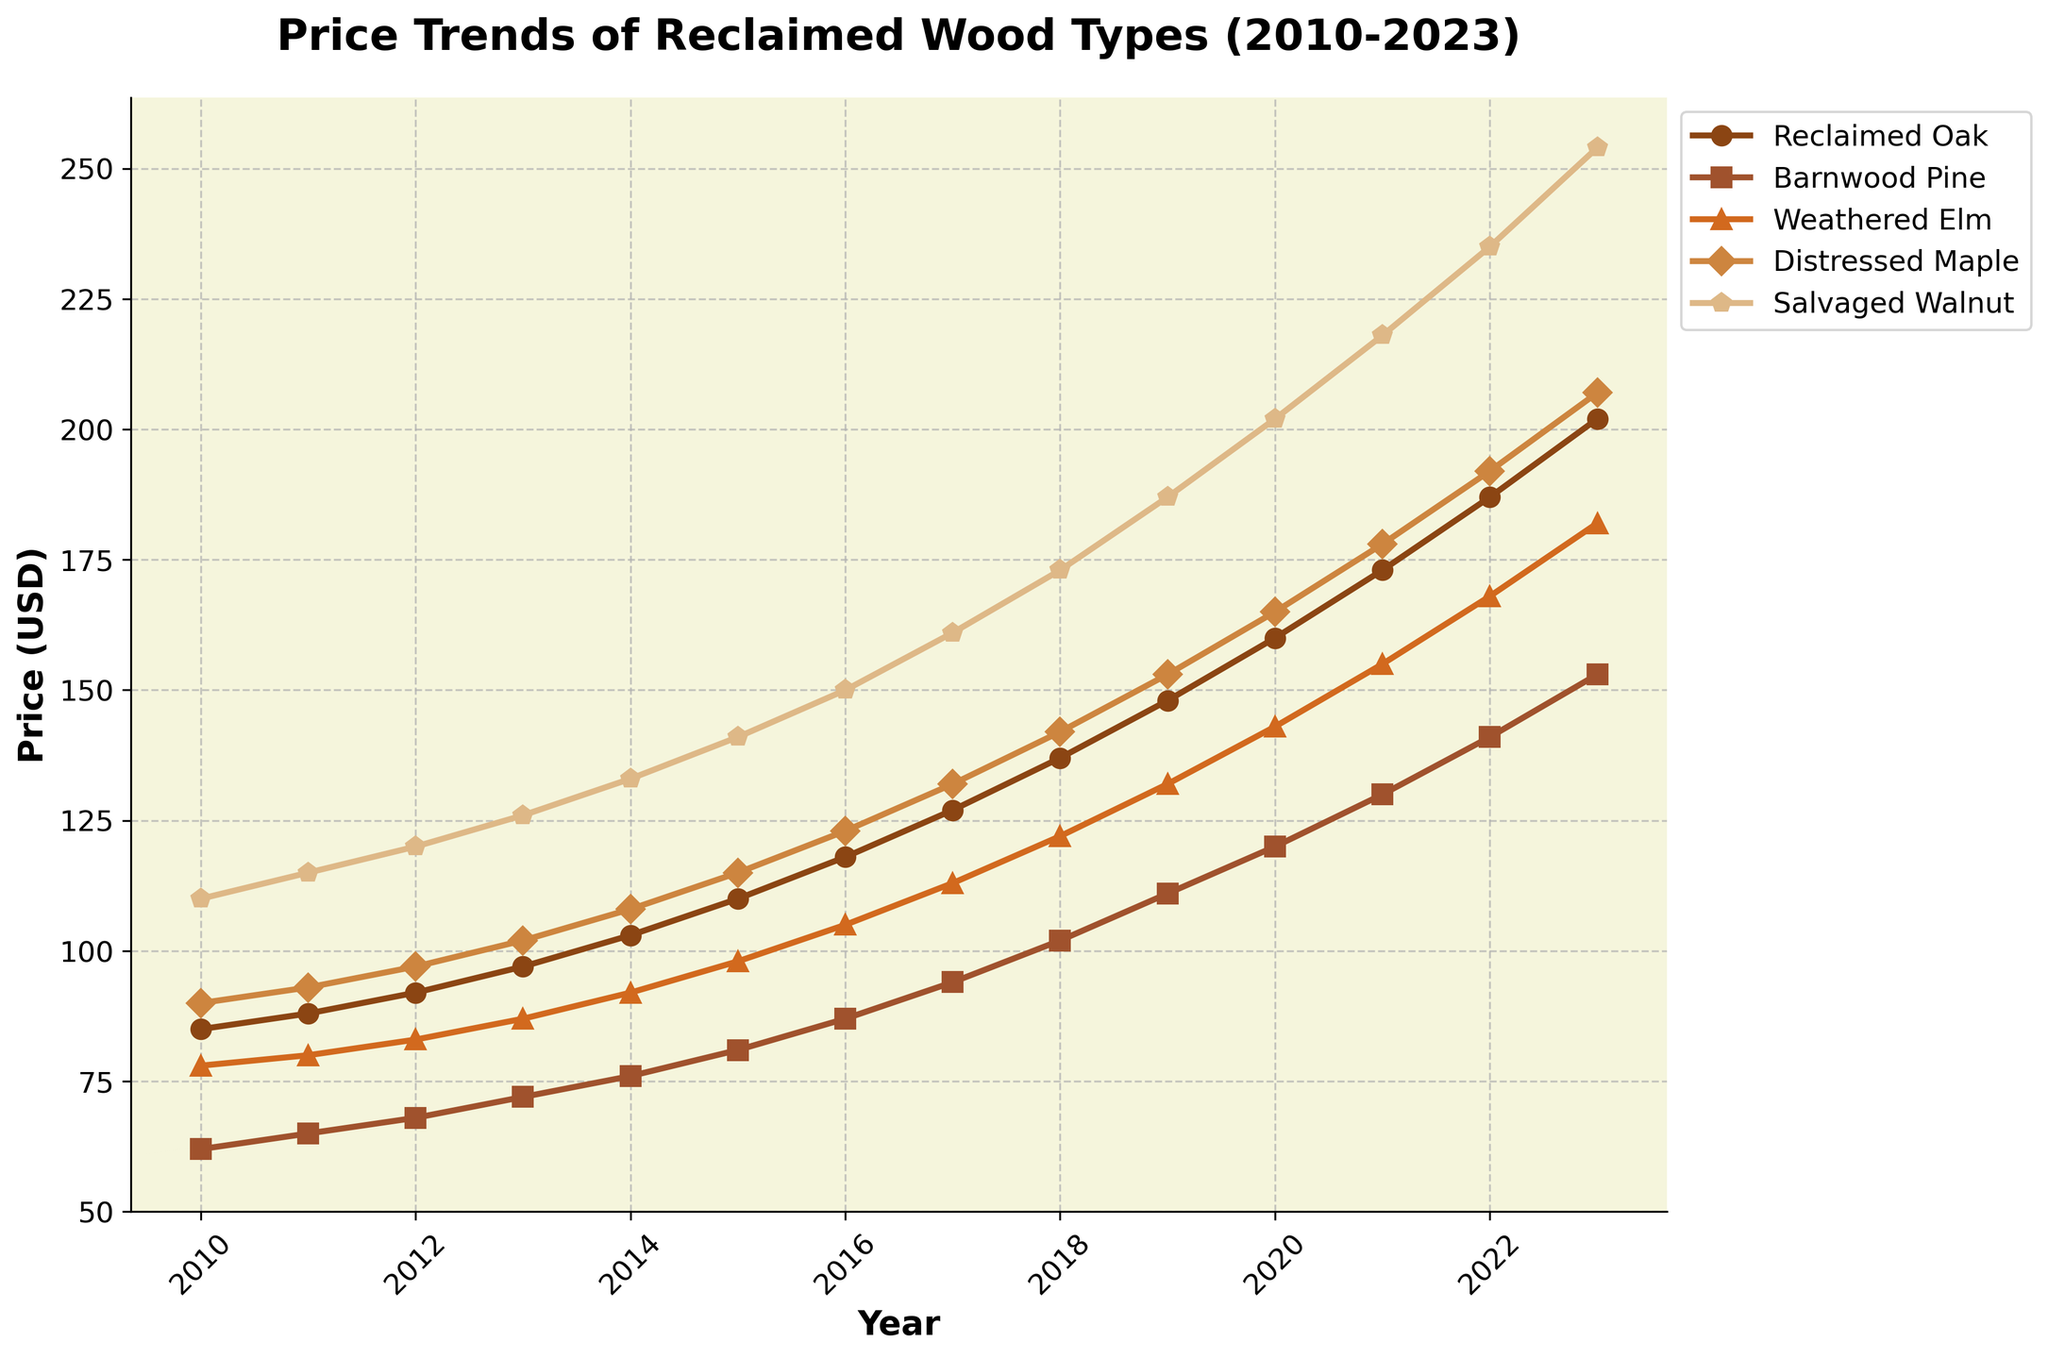What is the overall trend in the price of Reclaimed Oak from 2010 to 2023? The price of Reclaimed Oak shows a consistent upward trend from 2010 to 2023. Initially, in 2010, the price is $85, and it progressively increases each year, reaching $202 by 2023.
Answer: Upward trend How does the price of Salvaged Walnut in 2013 compare to the price of Distressed Maple in the same year? In 2013, the price of Salvaged Walnut is $126, whereas the price of Distressed Maple is $102. Thus, the price of Salvaged Walnut is higher than that of Distressed Maple in 2013.
Answer: Higher Which wood type experienced the steepest increase in price from 2019 to 2023? From 2019 to 2023, Salvaged Walnut increased from $187 to $254, an increase of $67. Reclaimed Oak increased by $54, Barnwood Pine by $42, Weathered Elm by $50, and Distressed Maple by $54. Salvaged Walnut experienced the steepest increase.
Answer: Salvaged Walnut What are the price differences between the most expensive and least expensive wood types in 2021? In 2021, the most expensive wood type is Salvaged Walnut at $218, and the least expensive is Barnwood Pine at $130. The price difference is $218 - $130 = $88.
Answer: $88 Which wood type had the smallest price increase from 2010 to 2023? Reclaimed Oak increased from $85 to $202 (an increase of $117), Barnwood Pine from $62 to $153 (an increase of $91), Weathered Elm from $78 to $182 (an increase of $104), Distressed Maple from $90 to $207 (an increase of $117), and Salvaged Walnut from $110 to $254 (an increase of $144). Barnwood Pine had the smallest increase.
Answer: Barnwood Pine What is the average price of Weathered Elm over the entire period from 2010 to 2023? To find the average price: (78 + 80 + 83 + 87 + 92 + 98 + 105 + 113 + 122 + 132 + 143 + 155 + 168 + 182) / 14 = 1394 / 14 = 99.57
Answer: 99.57 How do the prices of all wood types compare in 2015? In 2015: Reclaimed Oak is $110, Barnwood Pine is $81, Weathered Elm is $98, Distressed Maple is $115, and Salvaged Walnut is $141. Distressed Maple is the most expensive, and Barnwood Pine is the least expensive.
Answer: Distressed Maple is the most expensive, Barnwood Pine is the least expensive Which wood type has the most linear trend in its price increases? Reclaimed Oak shows a price increase from $85 to $202, following a seemingly linear pattern over the years, compared to the other types which seem to have more fluctuating increments.
Answer: Reclaimed Oak 